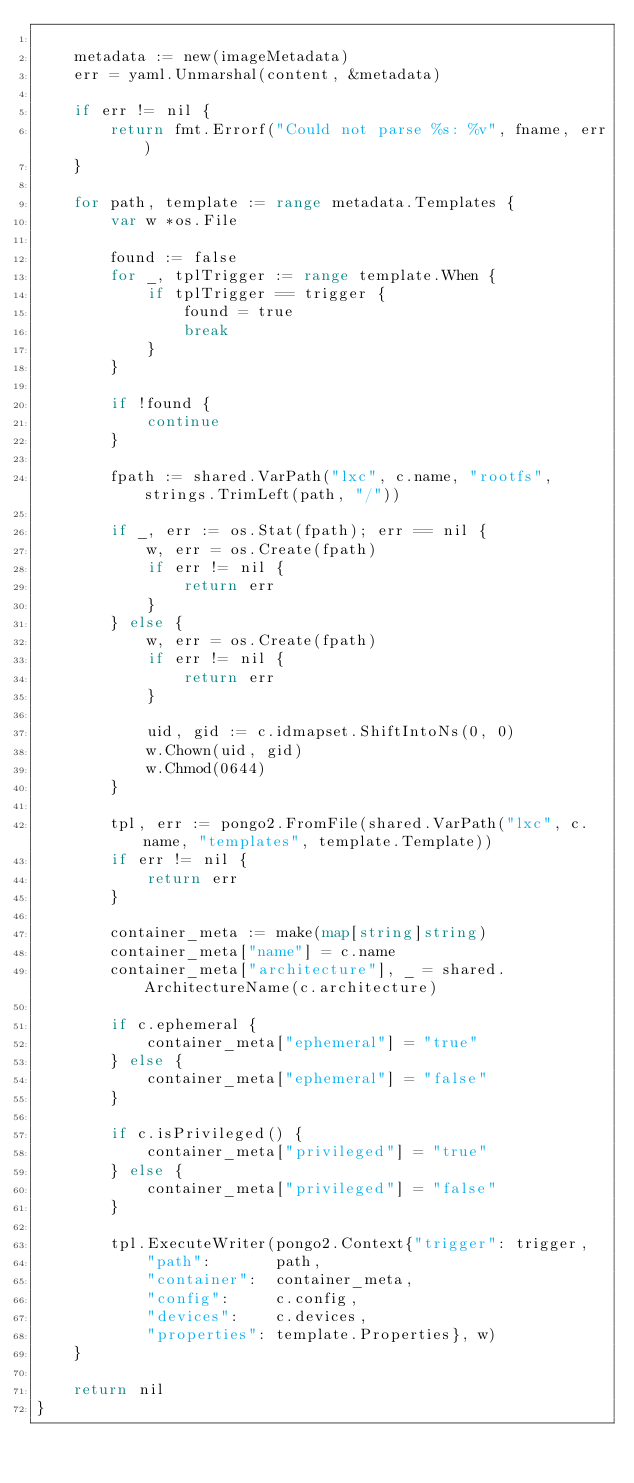Convert code to text. <code><loc_0><loc_0><loc_500><loc_500><_Go_>
	metadata := new(imageMetadata)
	err = yaml.Unmarshal(content, &metadata)

	if err != nil {
		return fmt.Errorf("Could not parse %s: %v", fname, err)
	}

	for path, template := range metadata.Templates {
		var w *os.File

		found := false
		for _, tplTrigger := range template.When {
			if tplTrigger == trigger {
				found = true
				break
			}
		}

		if !found {
			continue
		}

		fpath := shared.VarPath("lxc", c.name, "rootfs", strings.TrimLeft(path, "/"))

		if _, err := os.Stat(fpath); err == nil {
			w, err = os.Create(fpath)
			if err != nil {
				return err
			}
		} else {
			w, err = os.Create(fpath)
			if err != nil {
				return err
			}

			uid, gid := c.idmapset.ShiftIntoNs(0, 0)
			w.Chown(uid, gid)
			w.Chmod(0644)
		}

		tpl, err := pongo2.FromFile(shared.VarPath("lxc", c.name, "templates", template.Template))
		if err != nil {
			return err
		}

		container_meta := make(map[string]string)
		container_meta["name"] = c.name
		container_meta["architecture"], _ = shared.ArchitectureName(c.architecture)

		if c.ephemeral {
			container_meta["ephemeral"] = "true"
		} else {
			container_meta["ephemeral"] = "false"
		}

		if c.isPrivileged() {
			container_meta["privileged"] = "true"
		} else {
			container_meta["privileged"] = "false"
		}

		tpl.ExecuteWriter(pongo2.Context{"trigger": trigger,
			"path":       path,
			"container":  container_meta,
			"config":     c.config,
			"devices":    c.devices,
			"properties": template.Properties}, w)
	}

	return nil
}
</code> 